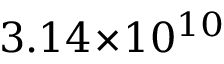<formula> <loc_0><loc_0><loc_500><loc_500>3 . 1 4 \, \times \, 1 0 ^ { 1 0 }</formula> 